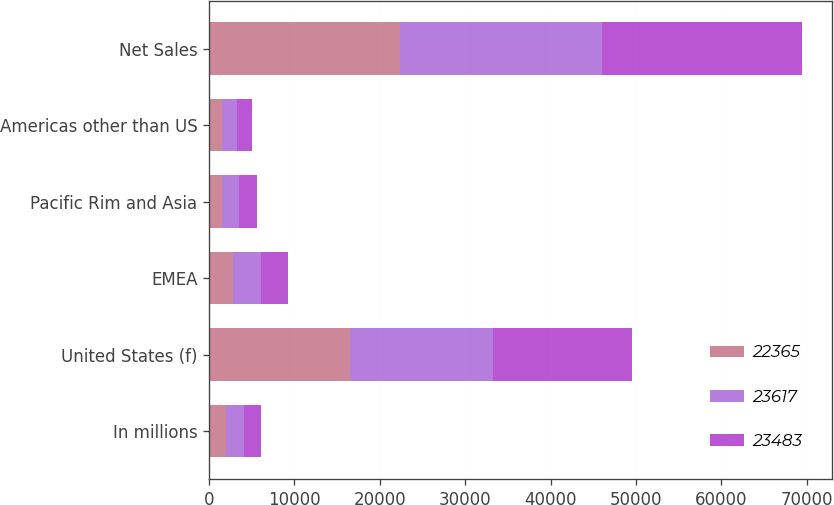<chart> <loc_0><loc_0><loc_500><loc_500><stacked_bar_chart><ecel><fcel>In millions<fcel>United States (f)<fcel>EMEA<fcel>Pacific Rim and Asia<fcel>Americas other than US<fcel>Net Sales<nl><fcel>22365<fcel>2015<fcel>16554<fcel>2770<fcel>1501<fcel>1540<fcel>22365<nl><fcel>23617<fcel>2014<fcel>16645<fcel>3273<fcel>1951<fcel>1748<fcel>23617<nl><fcel>23483<fcel>2013<fcel>16371<fcel>3250<fcel>2114<fcel>1748<fcel>23483<nl></chart> 